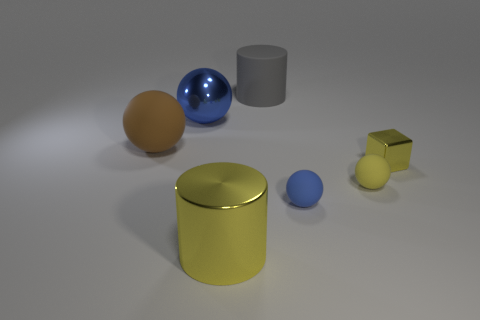There is a ball that is the same color as the shiny block; what is its size?
Your answer should be very brief. Small. There is a tiny cube that is the same color as the metal cylinder; what is it made of?
Provide a short and direct response. Metal. There is a metallic thing on the right side of the big gray matte thing; is its color the same as the big metal thing to the right of the large blue ball?
Offer a terse response. Yes. There is a cylinder in front of the big metal sphere; is its color the same as the small cube?
Provide a succinct answer. Yes. What is the thing that is both behind the large brown rubber thing and right of the yellow cylinder made of?
Offer a very short reply. Rubber. There is a blue ball behind the brown object; is there a big shiny object that is in front of it?
Give a very brief answer. Yes. Is the material of the small block the same as the big blue object?
Your response must be concise. Yes. What is the shape of the matte thing that is behind the small yellow rubber object and in front of the rubber cylinder?
Give a very brief answer. Sphere. How big is the cylinder behind the yellow metallic object on the right side of the big matte cylinder?
Your answer should be very brief. Large. What number of brown matte objects have the same shape as the big yellow shiny object?
Give a very brief answer. 0. 